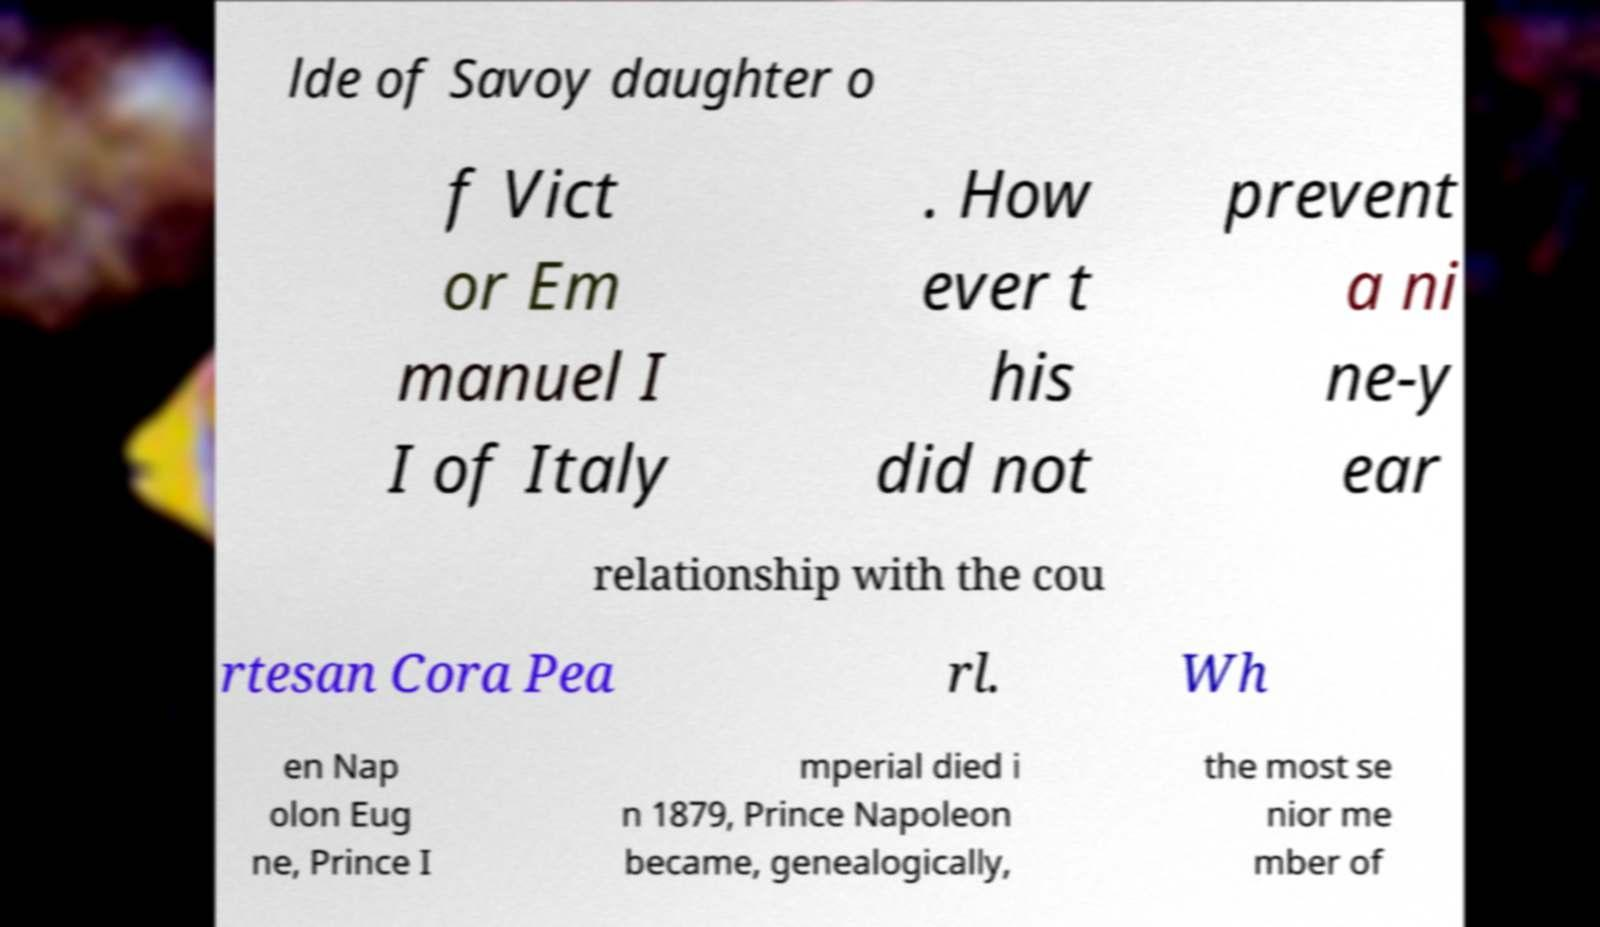Could you extract and type out the text from this image? lde of Savoy daughter o f Vict or Em manuel I I of Italy . How ever t his did not prevent a ni ne-y ear relationship with the cou rtesan Cora Pea rl. Wh en Nap olon Eug ne, Prince I mperial died i n 1879, Prince Napoleon became, genealogically, the most se nior me mber of 